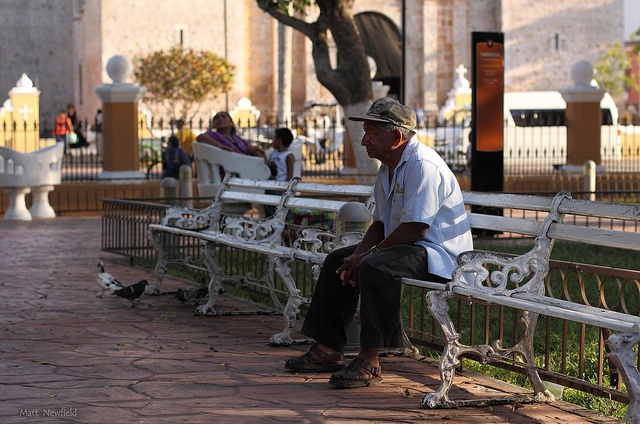Describe the objects in this image and their specific colors. I can see bench in gray, black, and darkgray tones, people in gray, black, and lightgray tones, bus in gray, ivory, black, beige, and darkgray tones, people in gray, black, and purple tones, and people in gray and black tones in this image. 